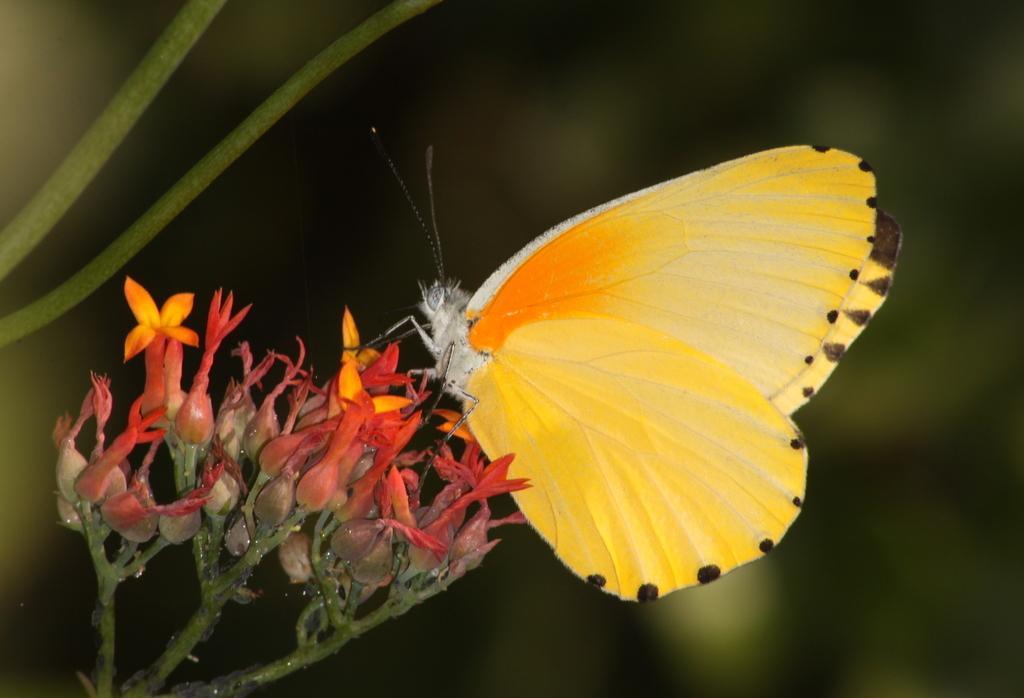Can you describe this image briefly? In this image we can see a butterfly on the flowers, there are buds, and stems, also the background is blurred. 